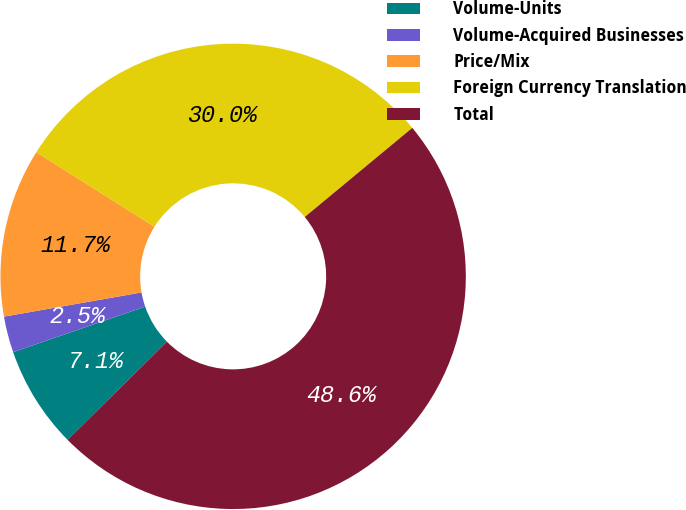Convert chart to OTSL. <chart><loc_0><loc_0><loc_500><loc_500><pie_chart><fcel>Volume-Units<fcel>Volume-Acquired Businesses<fcel>Price/Mix<fcel>Foreign Currency Translation<fcel>Total<nl><fcel>7.12%<fcel>2.51%<fcel>11.73%<fcel>30.03%<fcel>48.62%<nl></chart> 